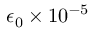<formula> <loc_0><loc_0><loc_500><loc_500>\epsilon _ { 0 } \times 1 0 ^ { - 5 }</formula> 